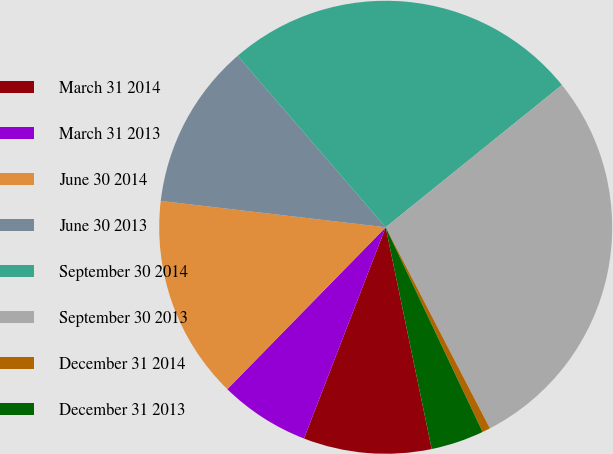<chart> <loc_0><loc_0><loc_500><loc_500><pie_chart><fcel>March 31 2014<fcel>March 31 2013<fcel>June 30 2014<fcel>June 30 2013<fcel>September 30 2014<fcel>September 30 2013<fcel>December 31 2014<fcel>December 31 2013<nl><fcel>9.13%<fcel>6.45%<fcel>14.53%<fcel>11.81%<fcel>25.52%<fcel>28.2%<fcel>0.57%<fcel>3.78%<nl></chart> 